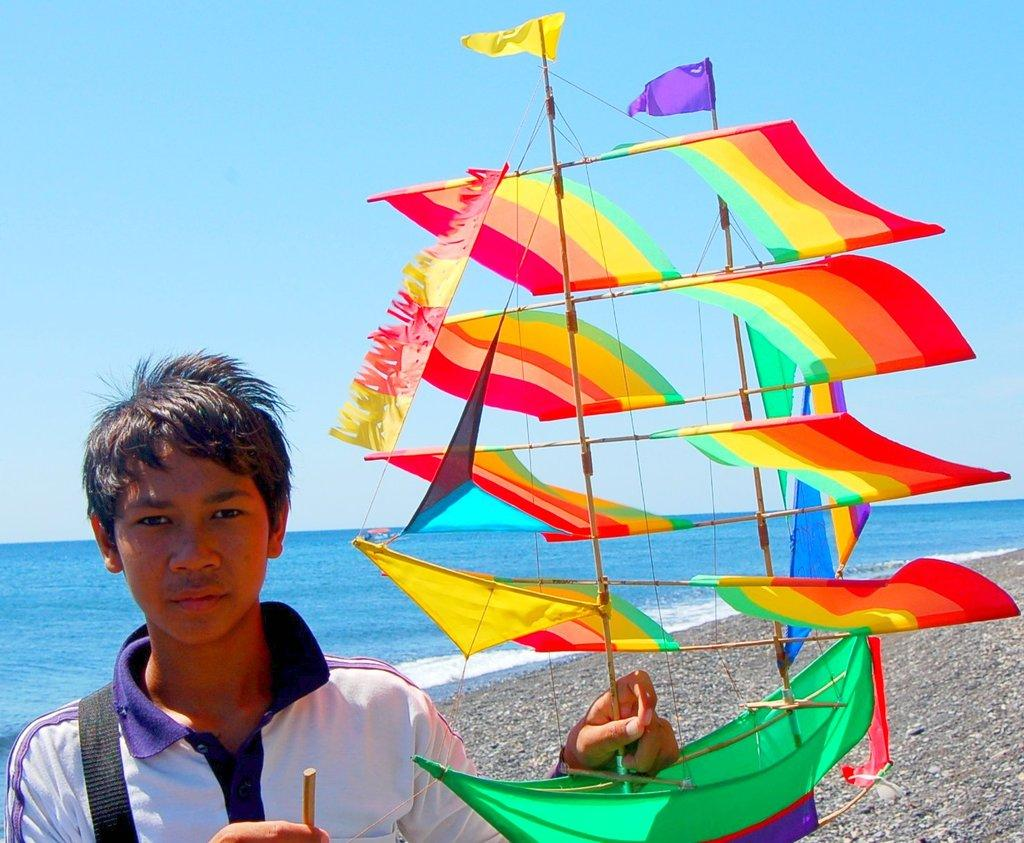Who is present in the image? There is a man in the image. What is the man doing in the image? The man is standing on the ground and holding a ship model in his hands. What can be seen in the background of the image? There is a sea and sky visible in the background of the image. What is the history of the bike in the image? There is no bike present in the image, so there is no history to discuss. 